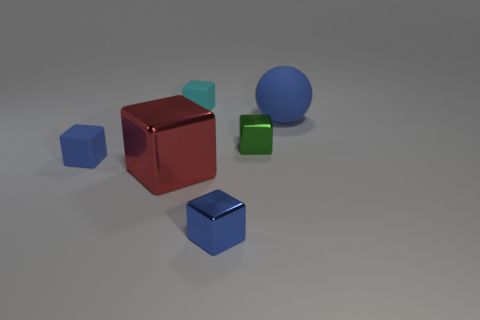There is a matte block that is the same color as the big rubber thing; what size is it?
Ensure brevity in your answer.  Small. Are there any green things made of the same material as the cyan thing?
Offer a very short reply. No. Are there an equal number of large blue rubber spheres in front of the small green cube and blue rubber things in front of the large blue rubber thing?
Your answer should be very brief. No. There is a matte object that is in front of the small green metallic cube; how big is it?
Your answer should be very brief. Small. There is a small cube that is on the left side of the large thing that is on the left side of the green shiny cube; what is its material?
Provide a succinct answer. Rubber. What number of large balls are on the right side of the blue object that is behind the blue rubber thing on the left side of the tiny cyan matte block?
Your response must be concise. 0. Is the blue object on the right side of the green shiny cube made of the same material as the small blue cube to the right of the small cyan matte thing?
Ensure brevity in your answer.  No. What number of other small metal objects have the same shape as the cyan thing?
Your answer should be compact. 2. Is the number of big red shiny things that are behind the blue metallic block greater than the number of tiny balls?
Make the answer very short. Yes. The blue thing that is left of the tiny rubber block to the right of the blue rubber object that is to the left of the small cyan object is what shape?
Your response must be concise. Cube. 